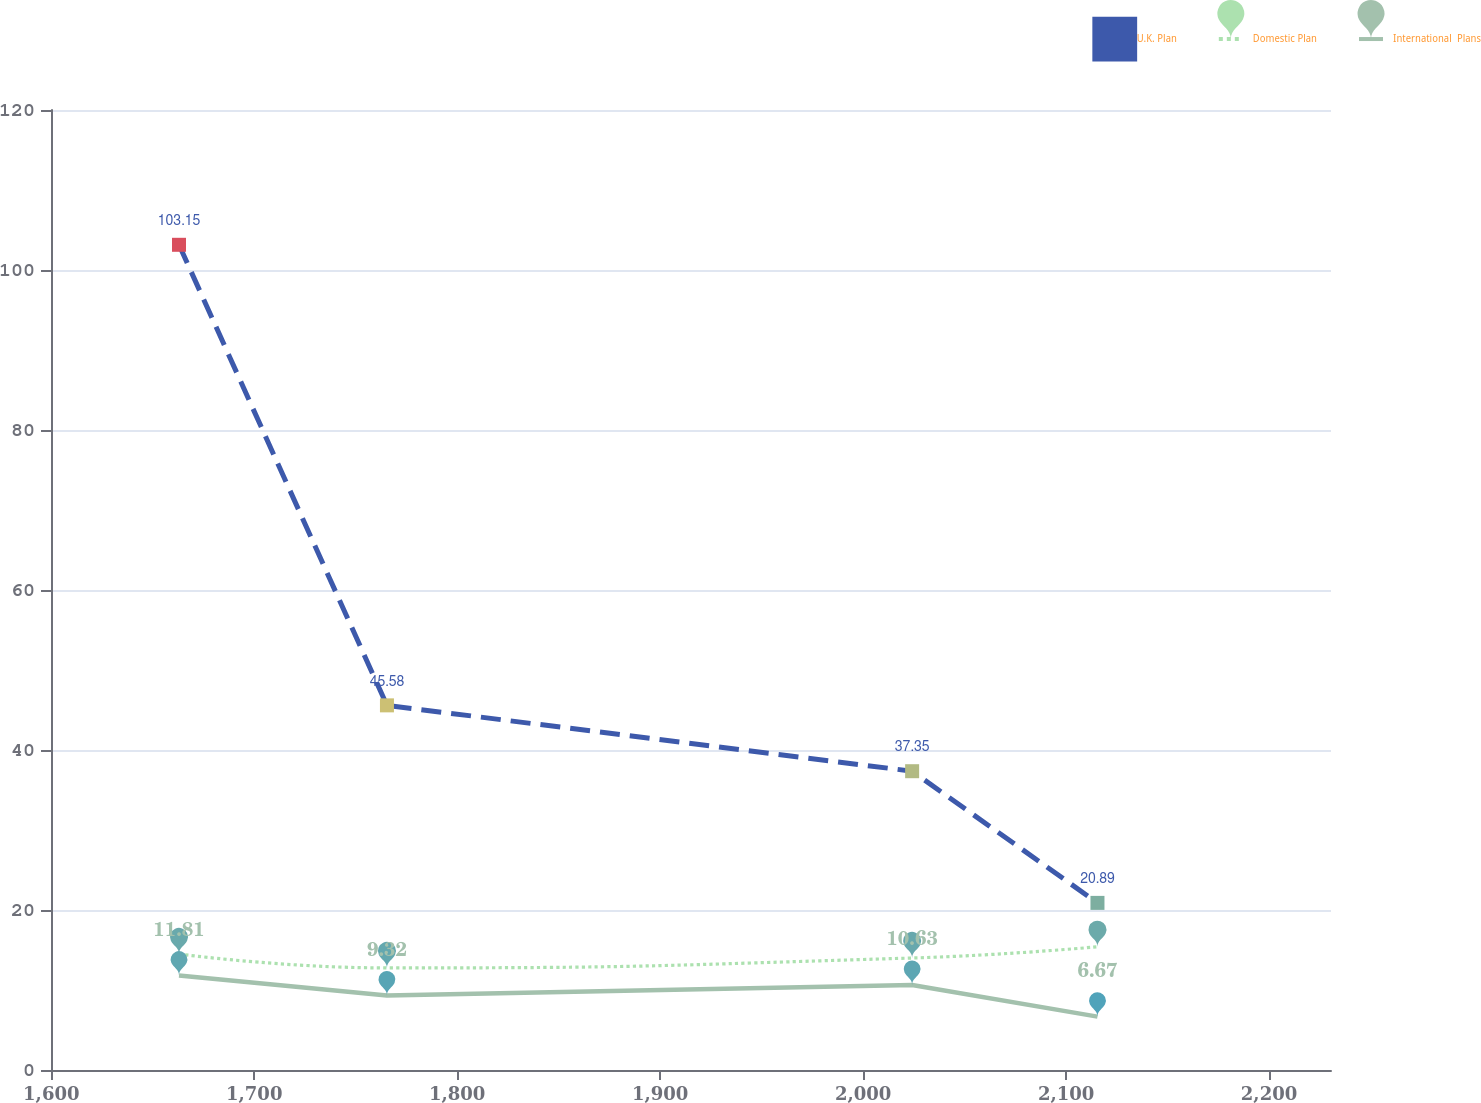<chart> <loc_0><loc_0><loc_500><loc_500><line_chart><ecel><fcel>U.K. Plan<fcel>Domestic Plan<fcel>International  Plans<nl><fcel>1662.93<fcel>103.15<fcel>14.5<fcel>11.81<nl><fcel>1765.39<fcel>45.58<fcel>12.76<fcel>9.32<nl><fcel>2024.15<fcel>37.35<fcel>14<fcel>10.63<nl><fcel>2115.47<fcel>20.89<fcel>15.4<fcel>6.67<nl><fcel>2293.6<fcel>29.12<fcel>17.76<fcel>7.18<nl></chart> 